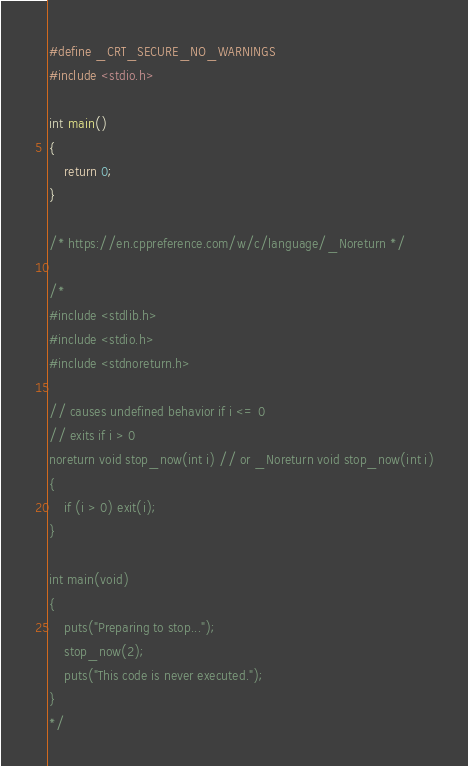<code> <loc_0><loc_0><loc_500><loc_500><_C_>#define _CRT_SECURE_NO_WARNINGS
#include <stdio.h>

int main()
{
	return 0;
}

/* https://en.cppreference.com/w/c/language/_Noreturn */

/*
#include <stdlib.h>
#include <stdio.h>
#include <stdnoreturn.h>

// causes undefined behavior if i <= 0
// exits if i > 0
noreturn void stop_now(int i) // or _Noreturn void stop_now(int i)
{
	if (i > 0) exit(i);
}

int main(void)
{
	puts("Preparing to stop...");
	stop_now(2);
	puts("This code is never executed.");
}
*/</code> 